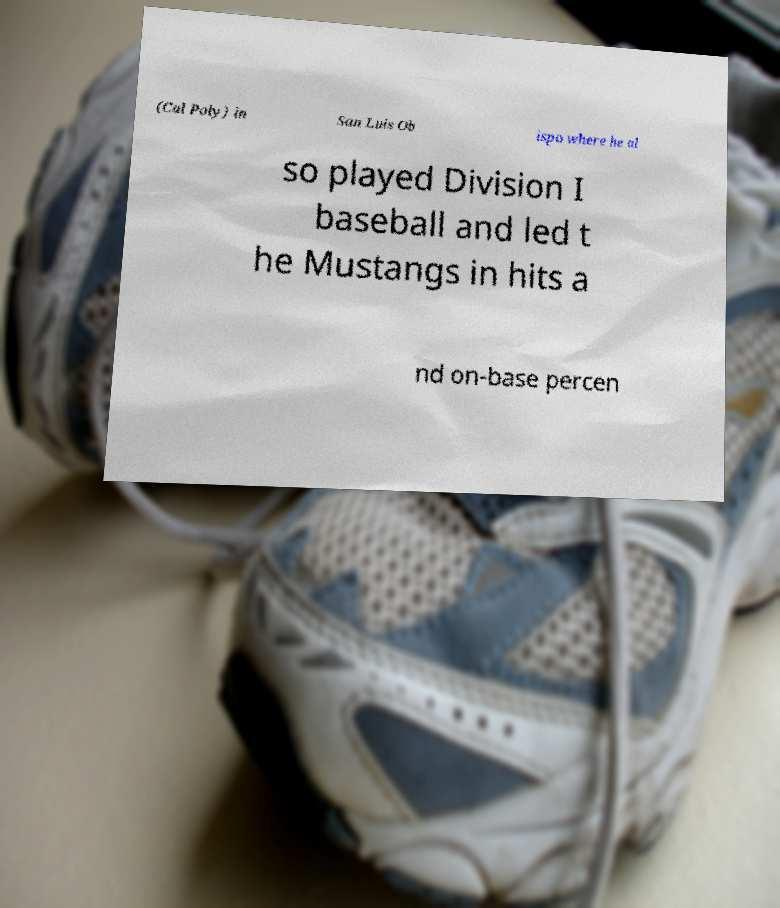There's text embedded in this image that I need extracted. Can you transcribe it verbatim? (Cal Poly) in San Luis Ob ispo where he al so played Division I baseball and led t he Mustangs in hits a nd on-base percen 